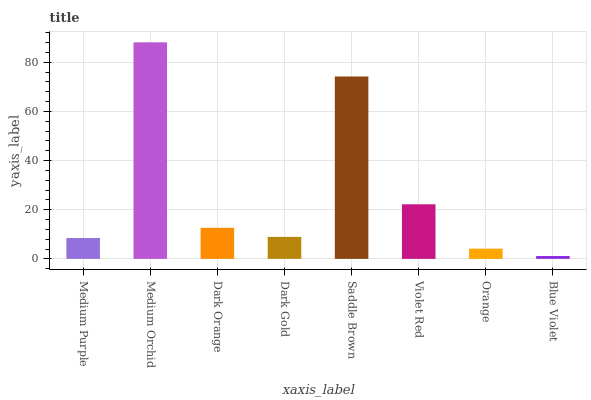Is Blue Violet the minimum?
Answer yes or no. Yes. Is Medium Orchid the maximum?
Answer yes or no. Yes. Is Dark Orange the minimum?
Answer yes or no. No. Is Dark Orange the maximum?
Answer yes or no. No. Is Medium Orchid greater than Dark Orange?
Answer yes or no. Yes. Is Dark Orange less than Medium Orchid?
Answer yes or no. Yes. Is Dark Orange greater than Medium Orchid?
Answer yes or no. No. Is Medium Orchid less than Dark Orange?
Answer yes or no. No. Is Dark Orange the high median?
Answer yes or no. Yes. Is Dark Gold the low median?
Answer yes or no. Yes. Is Blue Violet the high median?
Answer yes or no. No. Is Medium Purple the low median?
Answer yes or no. No. 